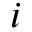<formula> <loc_0><loc_0><loc_500><loc_500>i</formula> 